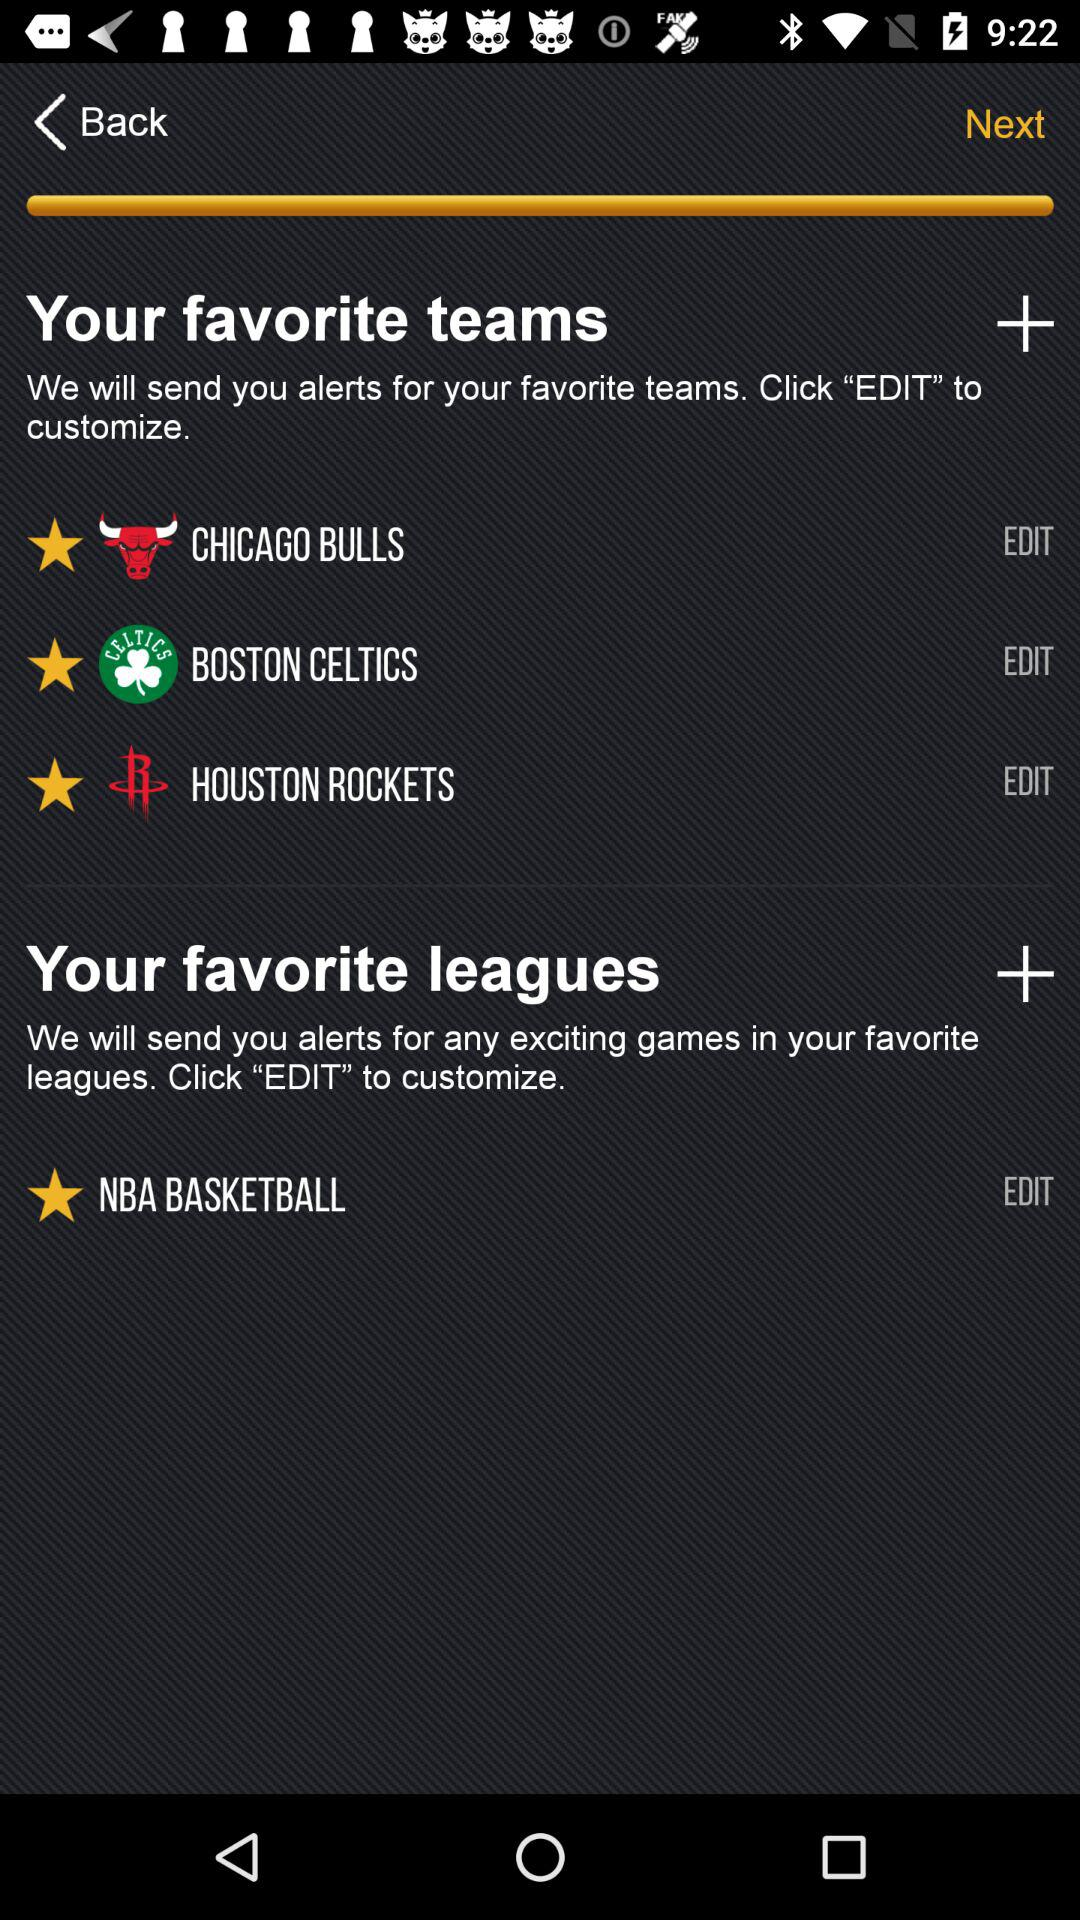What is the option in "Your favorite leagues"? The option is "NBA BASKETBALL". 